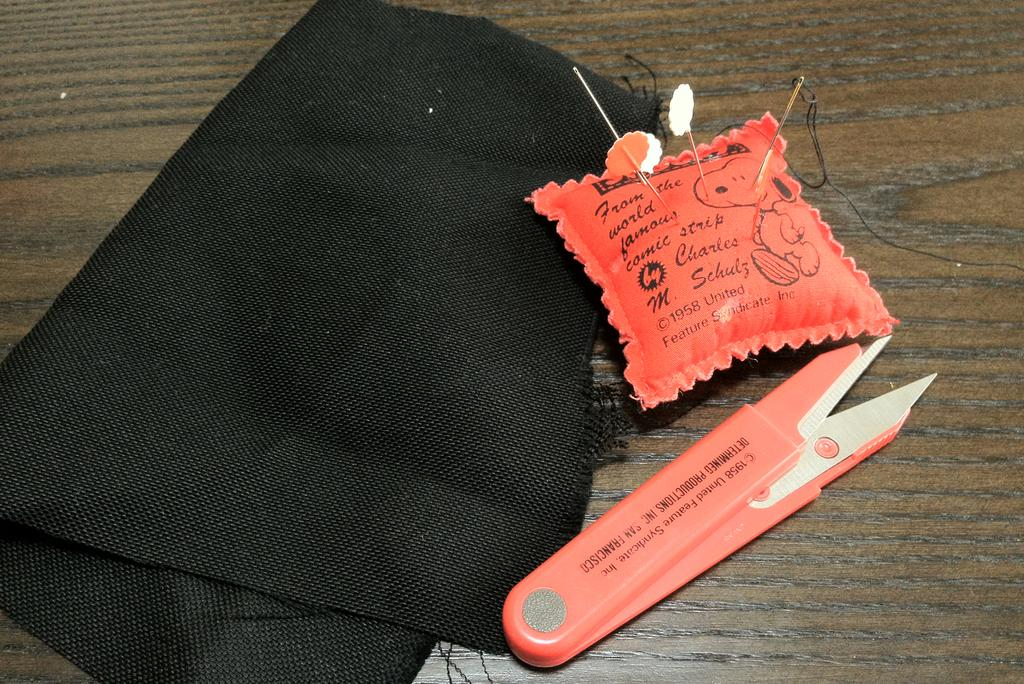<image>
Present a compact description of the photo's key features. A red pin cushion says Charles M. Schulz on it and has a picture of Snoopy. 